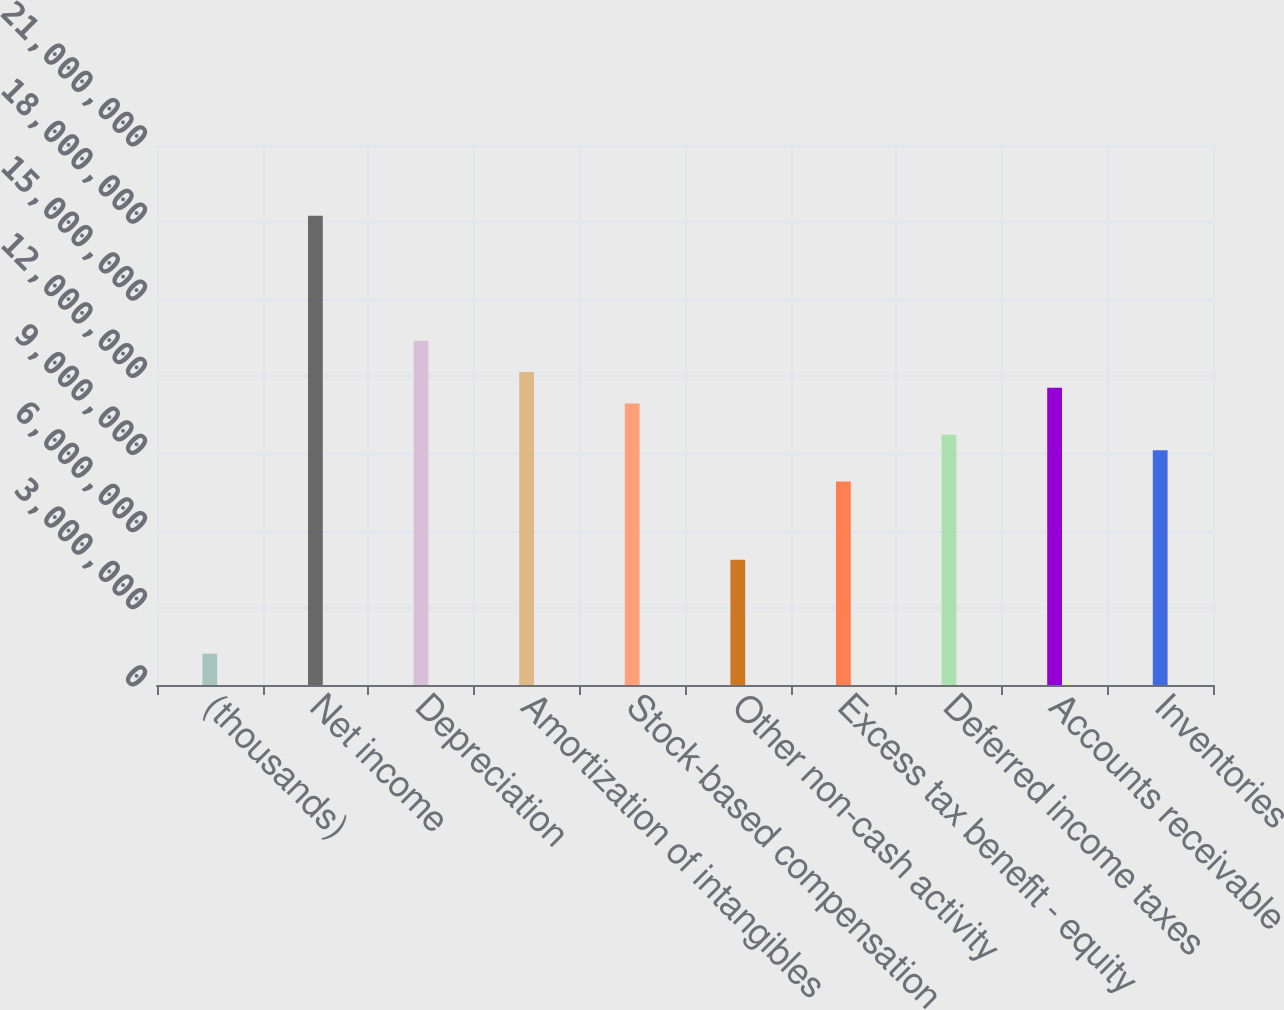Convert chart to OTSL. <chart><loc_0><loc_0><loc_500><loc_500><bar_chart><fcel>(thousands)<fcel>Net income<fcel>Depreciation<fcel>Amortization of intangibles<fcel>Stock-based compensation<fcel>Other non-cash activity<fcel>Excess tax benefit - equity<fcel>Deferred income taxes<fcel>Accounts receivable<fcel>Inventories<nl><fcel>1.2172e+06<fcel>1.8251e+07<fcel>1.33842e+07<fcel>1.21675e+07<fcel>1.09508e+07<fcel>4.8673e+06<fcel>7.90905e+06<fcel>9.7341e+06<fcel>1.15591e+07<fcel>9.12575e+06<nl></chart> 